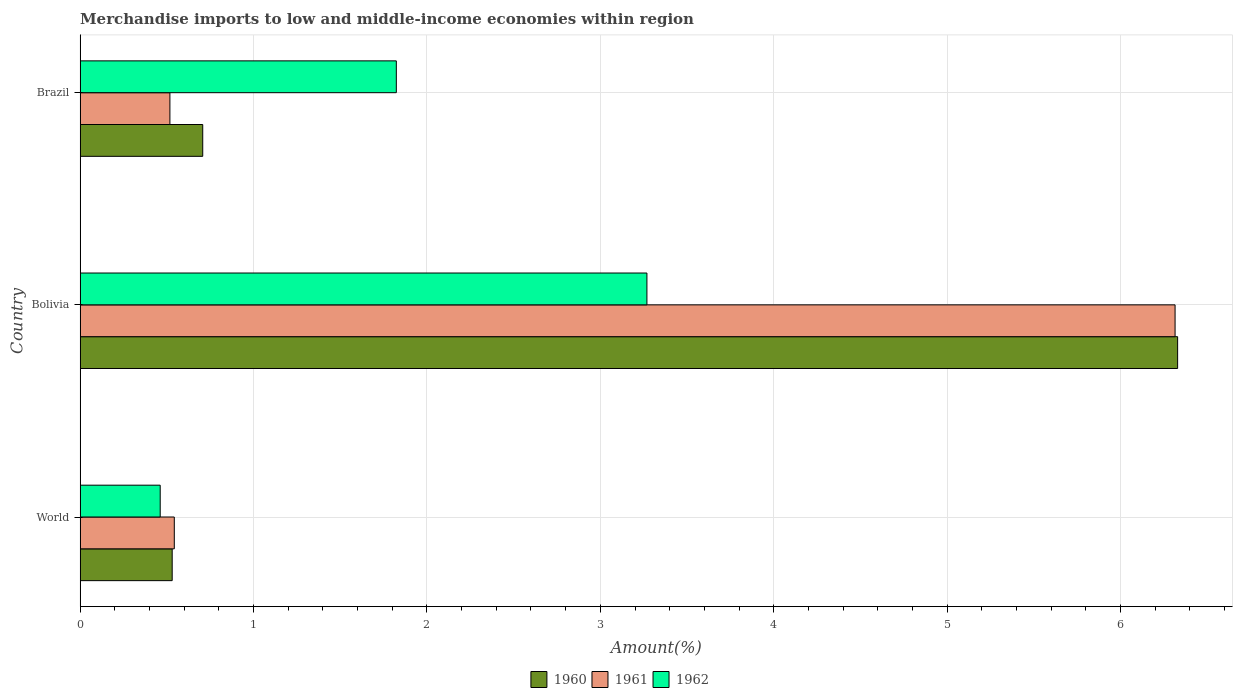How many groups of bars are there?
Provide a short and direct response. 3. Are the number of bars per tick equal to the number of legend labels?
Your answer should be very brief. Yes. How many bars are there on the 1st tick from the bottom?
Your answer should be very brief. 3. What is the label of the 1st group of bars from the top?
Offer a very short reply. Brazil. In how many cases, is the number of bars for a given country not equal to the number of legend labels?
Ensure brevity in your answer.  0. What is the percentage of amount earned from merchandise imports in 1960 in Bolivia?
Ensure brevity in your answer.  6.33. Across all countries, what is the maximum percentage of amount earned from merchandise imports in 1961?
Your response must be concise. 6.31. Across all countries, what is the minimum percentage of amount earned from merchandise imports in 1960?
Offer a very short reply. 0.53. In which country was the percentage of amount earned from merchandise imports in 1960 maximum?
Make the answer very short. Bolivia. In which country was the percentage of amount earned from merchandise imports in 1960 minimum?
Ensure brevity in your answer.  World. What is the total percentage of amount earned from merchandise imports in 1961 in the graph?
Ensure brevity in your answer.  7.38. What is the difference between the percentage of amount earned from merchandise imports in 1961 in Bolivia and that in World?
Make the answer very short. 5.77. What is the difference between the percentage of amount earned from merchandise imports in 1961 in Brazil and the percentage of amount earned from merchandise imports in 1962 in World?
Provide a succinct answer. 0.06. What is the average percentage of amount earned from merchandise imports in 1960 per country?
Ensure brevity in your answer.  2.52. What is the difference between the percentage of amount earned from merchandise imports in 1962 and percentage of amount earned from merchandise imports in 1961 in Bolivia?
Give a very brief answer. -3.05. In how many countries, is the percentage of amount earned from merchandise imports in 1960 greater than 0.2 %?
Offer a terse response. 3. What is the ratio of the percentage of amount earned from merchandise imports in 1960 in Bolivia to that in World?
Your answer should be compact. 11.92. Is the percentage of amount earned from merchandise imports in 1962 in Bolivia less than that in World?
Your answer should be compact. No. Is the difference between the percentage of amount earned from merchandise imports in 1962 in Bolivia and World greater than the difference between the percentage of amount earned from merchandise imports in 1961 in Bolivia and World?
Offer a very short reply. No. What is the difference between the highest and the second highest percentage of amount earned from merchandise imports in 1962?
Keep it short and to the point. 1.45. What is the difference between the highest and the lowest percentage of amount earned from merchandise imports in 1961?
Give a very brief answer. 5.8. Is the sum of the percentage of amount earned from merchandise imports in 1962 in Bolivia and Brazil greater than the maximum percentage of amount earned from merchandise imports in 1961 across all countries?
Provide a short and direct response. No. How many countries are there in the graph?
Give a very brief answer. 3. What is the difference between two consecutive major ticks on the X-axis?
Offer a terse response. 1. Are the values on the major ticks of X-axis written in scientific E-notation?
Provide a succinct answer. No. Does the graph contain any zero values?
Make the answer very short. No. Does the graph contain grids?
Your answer should be very brief. Yes. Where does the legend appear in the graph?
Provide a short and direct response. Bottom center. How many legend labels are there?
Your answer should be very brief. 3. How are the legend labels stacked?
Offer a terse response. Horizontal. What is the title of the graph?
Provide a short and direct response. Merchandise imports to low and middle-income economies within region. Does "2007" appear as one of the legend labels in the graph?
Your answer should be very brief. No. What is the label or title of the X-axis?
Give a very brief answer. Amount(%). What is the Amount(%) of 1960 in World?
Provide a succinct answer. 0.53. What is the Amount(%) in 1961 in World?
Offer a terse response. 0.54. What is the Amount(%) of 1962 in World?
Provide a short and direct response. 0.46. What is the Amount(%) in 1960 in Bolivia?
Your answer should be very brief. 6.33. What is the Amount(%) of 1961 in Bolivia?
Make the answer very short. 6.31. What is the Amount(%) in 1962 in Bolivia?
Make the answer very short. 3.27. What is the Amount(%) of 1960 in Brazil?
Offer a very short reply. 0.71. What is the Amount(%) of 1961 in Brazil?
Give a very brief answer. 0.52. What is the Amount(%) of 1962 in Brazil?
Make the answer very short. 1.82. Across all countries, what is the maximum Amount(%) of 1960?
Give a very brief answer. 6.33. Across all countries, what is the maximum Amount(%) in 1961?
Offer a terse response. 6.31. Across all countries, what is the maximum Amount(%) of 1962?
Ensure brevity in your answer.  3.27. Across all countries, what is the minimum Amount(%) of 1960?
Offer a terse response. 0.53. Across all countries, what is the minimum Amount(%) of 1961?
Your answer should be compact. 0.52. Across all countries, what is the minimum Amount(%) in 1962?
Provide a short and direct response. 0.46. What is the total Amount(%) in 1960 in the graph?
Your answer should be compact. 7.57. What is the total Amount(%) of 1961 in the graph?
Offer a terse response. 7.38. What is the total Amount(%) of 1962 in the graph?
Ensure brevity in your answer.  5.55. What is the difference between the Amount(%) of 1960 in World and that in Bolivia?
Ensure brevity in your answer.  -5.8. What is the difference between the Amount(%) of 1961 in World and that in Bolivia?
Offer a very short reply. -5.77. What is the difference between the Amount(%) in 1962 in World and that in Bolivia?
Offer a terse response. -2.81. What is the difference between the Amount(%) of 1960 in World and that in Brazil?
Provide a succinct answer. -0.18. What is the difference between the Amount(%) in 1961 in World and that in Brazil?
Your answer should be compact. 0.03. What is the difference between the Amount(%) of 1962 in World and that in Brazil?
Your answer should be compact. -1.36. What is the difference between the Amount(%) of 1960 in Bolivia and that in Brazil?
Provide a succinct answer. 5.62. What is the difference between the Amount(%) in 1961 in Bolivia and that in Brazil?
Make the answer very short. 5.8. What is the difference between the Amount(%) of 1962 in Bolivia and that in Brazil?
Your response must be concise. 1.45. What is the difference between the Amount(%) in 1960 in World and the Amount(%) in 1961 in Bolivia?
Ensure brevity in your answer.  -5.78. What is the difference between the Amount(%) of 1960 in World and the Amount(%) of 1962 in Bolivia?
Provide a short and direct response. -2.74. What is the difference between the Amount(%) of 1961 in World and the Amount(%) of 1962 in Bolivia?
Provide a short and direct response. -2.73. What is the difference between the Amount(%) in 1960 in World and the Amount(%) in 1961 in Brazil?
Your response must be concise. 0.01. What is the difference between the Amount(%) of 1960 in World and the Amount(%) of 1962 in Brazil?
Give a very brief answer. -1.29. What is the difference between the Amount(%) of 1961 in World and the Amount(%) of 1962 in Brazil?
Your answer should be very brief. -1.28. What is the difference between the Amount(%) of 1960 in Bolivia and the Amount(%) of 1961 in Brazil?
Make the answer very short. 5.81. What is the difference between the Amount(%) in 1960 in Bolivia and the Amount(%) in 1962 in Brazil?
Keep it short and to the point. 4.51. What is the difference between the Amount(%) of 1961 in Bolivia and the Amount(%) of 1962 in Brazil?
Offer a terse response. 4.49. What is the average Amount(%) in 1960 per country?
Keep it short and to the point. 2.52. What is the average Amount(%) in 1961 per country?
Offer a terse response. 2.46. What is the average Amount(%) in 1962 per country?
Make the answer very short. 1.85. What is the difference between the Amount(%) of 1960 and Amount(%) of 1961 in World?
Provide a short and direct response. -0.01. What is the difference between the Amount(%) in 1960 and Amount(%) in 1962 in World?
Offer a terse response. 0.07. What is the difference between the Amount(%) in 1961 and Amount(%) in 1962 in World?
Your response must be concise. 0.08. What is the difference between the Amount(%) in 1960 and Amount(%) in 1961 in Bolivia?
Your answer should be compact. 0.01. What is the difference between the Amount(%) in 1960 and Amount(%) in 1962 in Bolivia?
Provide a succinct answer. 3.06. What is the difference between the Amount(%) of 1961 and Amount(%) of 1962 in Bolivia?
Offer a very short reply. 3.05. What is the difference between the Amount(%) of 1960 and Amount(%) of 1961 in Brazil?
Give a very brief answer. 0.19. What is the difference between the Amount(%) in 1960 and Amount(%) in 1962 in Brazil?
Offer a terse response. -1.12. What is the difference between the Amount(%) in 1961 and Amount(%) in 1962 in Brazil?
Make the answer very short. -1.31. What is the ratio of the Amount(%) in 1960 in World to that in Bolivia?
Keep it short and to the point. 0.08. What is the ratio of the Amount(%) of 1961 in World to that in Bolivia?
Give a very brief answer. 0.09. What is the ratio of the Amount(%) in 1962 in World to that in Bolivia?
Your answer should be compact. 0.14. What is the ratio of the Amount(%) in 1960 in World to that in Brazil?
Your response must be concise. 0.75. What is the ratio of the Amount(%) of 1961 in World to that in Brazil?
Offer a terse response. 1.05. What is the ratio of the Amount(%) in 1962 in World to that in Brazil?
Ensure brevity in your answer.  0.25. What is the ratio of the Amount(%) in 1960 in Bolivia to that in Brazil?
Your response must be concise. 8.95. What is the ratio of the Amount(%) in 1961 in Bolivia to that in Brazil?
Provide a succinct answer. 12.2. What is the ratio of the Amount(%) of 1962 in Bolivia to that in Brazil?
Keep it short and to the point. 1.79. What is the difference between the highest and the second highest Amount(%) in 1960?
Keep it short and to the point. 5.62. What is the difference between the highest and the second highest Amount(%) of 1961?
Your answer should be compact. 5.77. What is the difference between the highest and the second highest Amount(%) in 1962?
Provide a short and direct response. 1.45. What is the difference between the highest and the lowest Amount(%) in 1960?
Ensure brevity in your answer.  5.8. What is the difference between the highest and the lowest Amount(%) in 1961?
Provide a short and direct response. 5.8. What is the difference between the highest and the lowest Amount(%) in 1962?
Give a very brief answer. 2.81. 